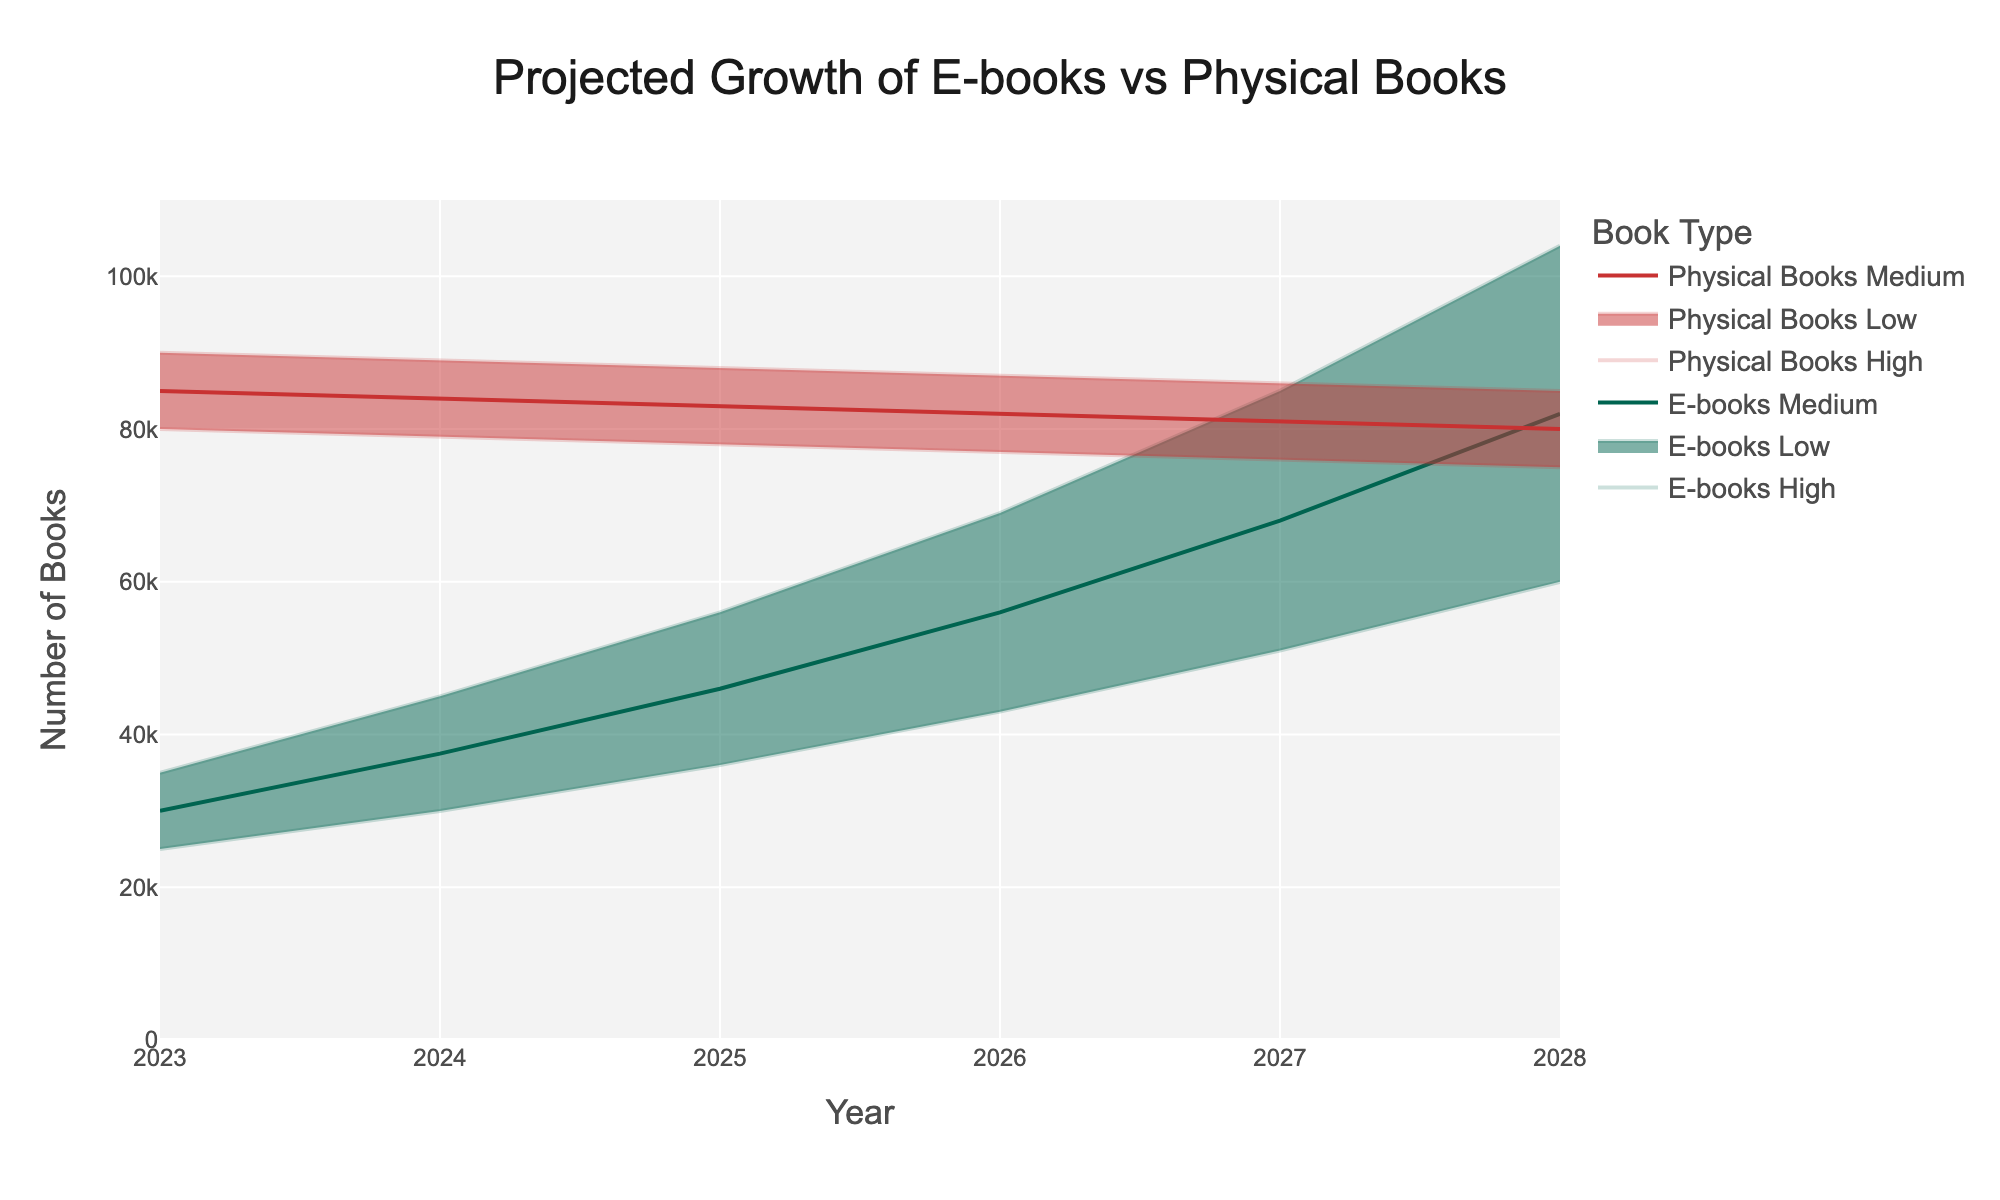What's the title of the figure? The title is usually found at the top of the figure and summarizes the main focus of the plot. In this case, it's centered at the top.
Answer: Projected Growth of E-books vs Physical Books What is the maximum estimated number of e-books in 2028? Look at the 'E-books High' line for the year 2028, which shows the upper bound of the projection for e-books.
Answer: 104,000 In which year is the number of physical books projected to be the lowest? Identify the lowest point of the 'Physical_Books_Low' line across all years. The lowest point appears in 2028.
Answer: 75,000 What is the projected range for the number of physical books in 2026? To find the range, subtract the value of 'Physical_Books_Low' from 'Physical_Books_High' for 2026. The highest is 87,000, and the lowest is 77,000.
Answer: 10,000 How does the projected median number of e-books in 2025 compare to the median number of physical books in the same year? Look at the 'E-books_Medium' and 'Physical_Books_Medium' lines for the year 2025. Compare the values for the median projections.
Answer: The median number of e-books (46,000) is less than the median number of physical books (83,000) in 2025 Between 2024 and 2026, how does the growth of the high estimate for e-books compare to the high estimate for physical books? Calculate the difference for the high estimates of both e-books and physical books between 2024 and 2026. For e-books, it grows from 45,000 to 69,000, an increase of 24,000; for physical books, it decreases from 89,000 to 87,000, a loss of 2,000.
Answer: The high estimate for e-books grows by 24,000, whereas the high estimate for physical books decreases by 2,000 What's the projected average number of e-books in 2027? To find the average, sum the low, medium, and high estimates for e-books in 2027 and divide by 3. (51,000 + 68,000 + 85,000) / 3 = 68,000.
Answer: 68,000 What trend is observed for the median projection of physical books from 2023 to 2028? Examine the 'Physical_Books_Medium' line and observe its overall shape from 2023 to 2028. It shows a declining trend.
Answer: The median projection for physical books is decreasing How much more are the high estimates of e-books compared to physical books in 2028? To find the difference, subtract the 'Physical_Books_High' value from the 'E-books_High' value for 2028. 104,000 - 85,000 = 19,000.
Answer: 19,000 